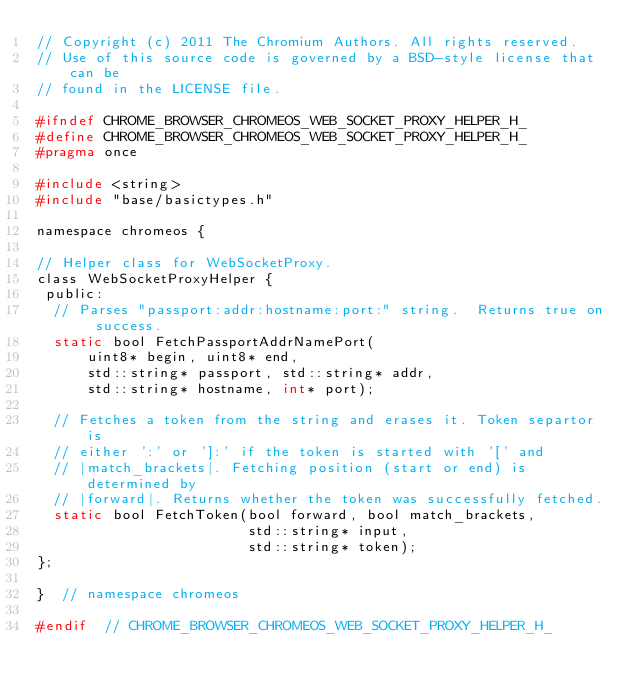<code> <loc_0><loc_0><loc_500><loc_500><_C_>// Copyright (c) 2011 The Chromium Authors. All rights reserved.
// Use of this source code is governed by a BSD-style license that can be
// found in the LICENSE file.

#ifndef CHROME_BROWSER_CHROMEOS_WEB_SOCKET_PROXY_HELPER_H_
#define CHROME_BROWSER_CHROMEOS_WEB_SOCKET_PROXY_HELPER_H_
#pragma once

#include <string>
#include "base/basictypes.h"

namespace chromeos {

// Helper class for WebSocketProxy.
class WebSocketProxyHelper {
 public:
  // Parses "passport:addr:hostname:port:" string.  Returns true on success.
  static bool FetchPassportAddrNamePort(
      uint8* begin, uint8* end,
      std::string* passport, std::string* addr,
      std::string* hostname, int* port);

  // Fetches a token from the string and erases it. Token separtor is
  // either ':' or ']:' if the token is started with '[' and
  // |match_brackets|. Fetching position (start or end) is determined by
  // |forward|. Returns whether the token was successfully fetched.
  static bool FetchToken(bool forward, bool match_brackets,
                         std::string* input,
                         std::string* token);
};

}  // namespace chromeos

#endif  // CHROME_BROWSER_CHROMEOS_WEB_SOCKET_PROXY_HELPER_H_
</code> 